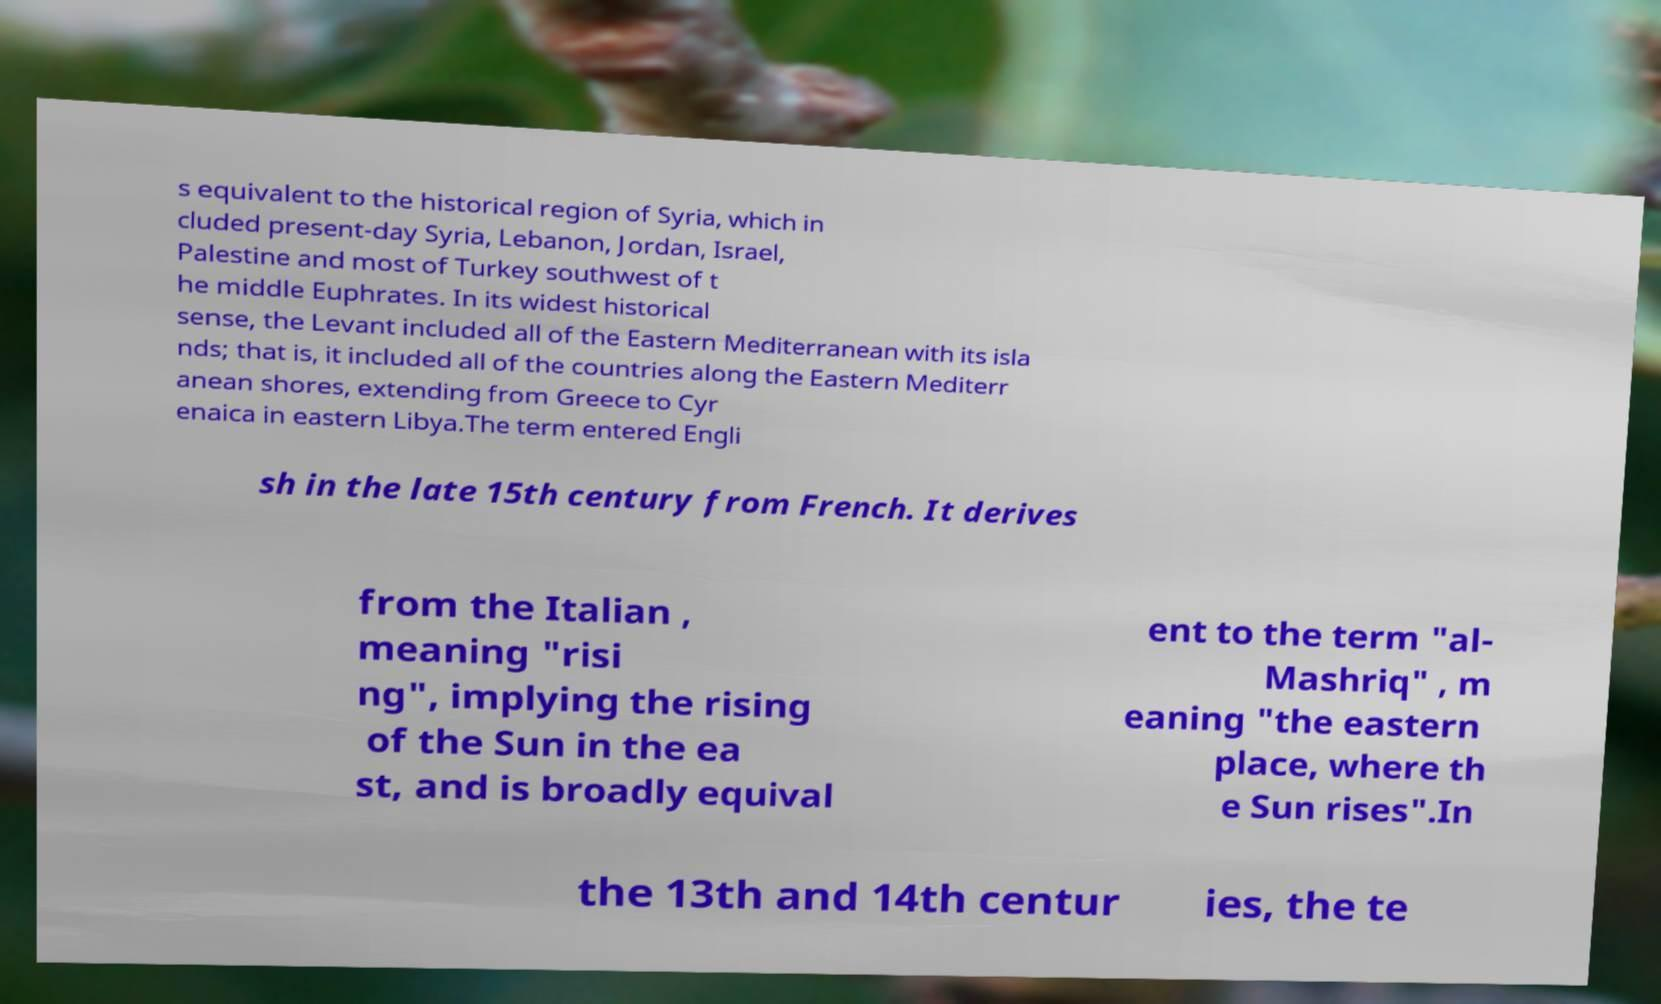Can you accurately transcribe the text from the provided image for me? s equivalent to the historical region of Syria, which in cluded present-day Syria, Lebanon, Jordan, Israel, Palestine and most of Turkey southwest of t he middle Euphrates. In its widest historical sense, the Levant included all of the Eastern Mediterranean with its isla nds; that is, it included all of the countries along the Eastern Mediterr anean shores, extending from Greece to Cyr enaica in eastern Libya.The term entered Engli sh in the late 15th century from French. It derives from the Italian , meaning "risi ng", implying the rising of the Sun in the ea st, and is broadly equival ent to the term "al- Mashriq" , m eaning "the eastern place, where th e Sun rises".In the 13th and 14th centur ies, the te 